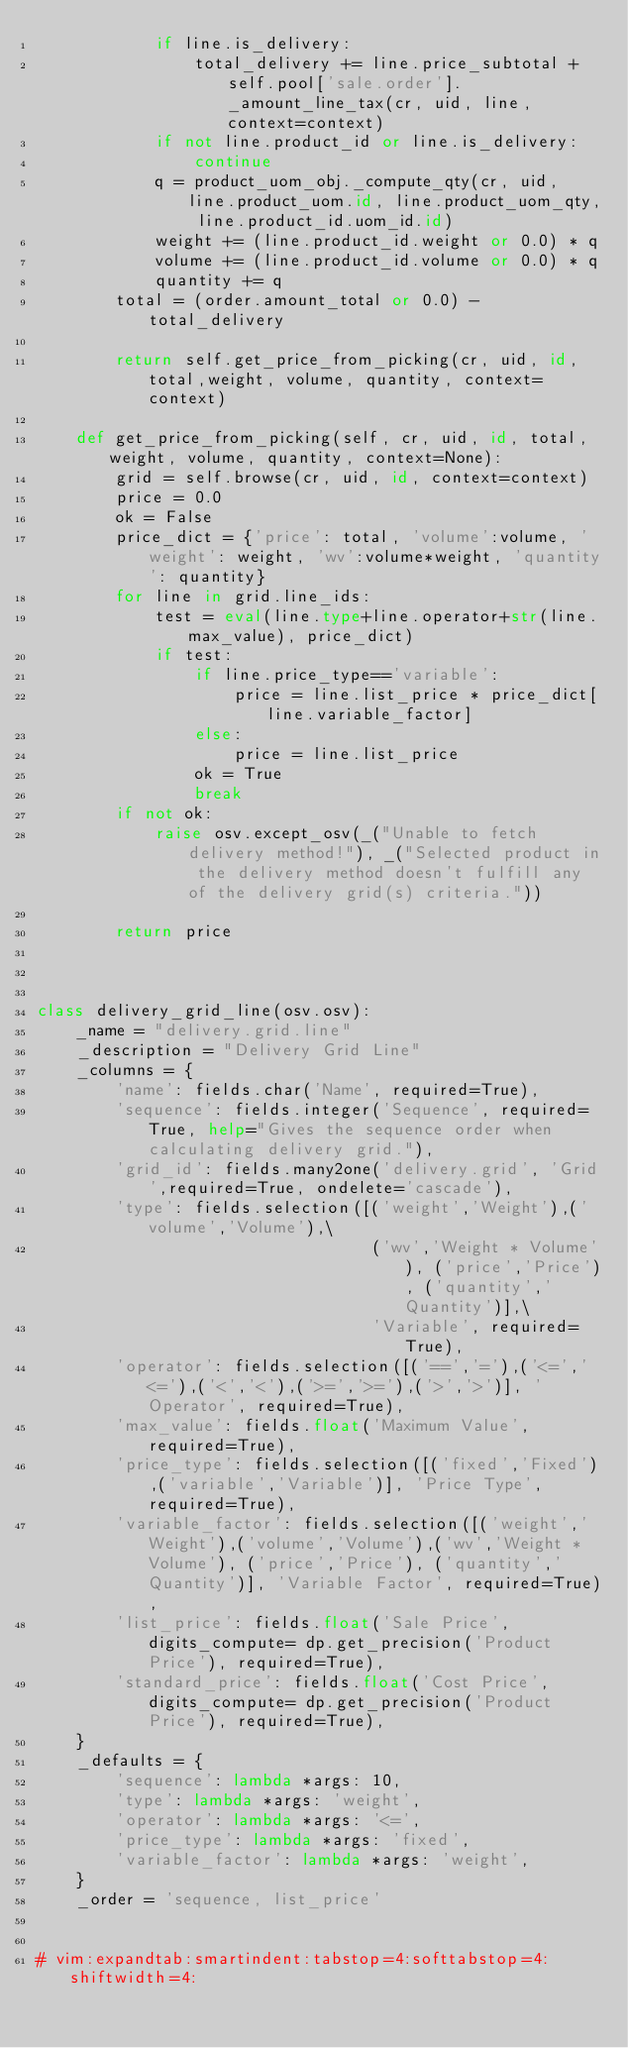<code> <loc_0><loc_0><loc_500><loc_500><_Python_>            if line.is_delivery:
                total_delivery += line.price_subtotal + self.pool['sale.order']._amount_line_tax(cr, uid, line, context=context)
            if not line.product_id or line.is_delivery:
                continue
            q = product_uom_obj._compute_qty(cr, uid, line.product_uom.id, line.product_uom_qty, line.product_id.uom_id.id)
            weight += (line.product_id.weight or 0.0) * q
            volume += (line.product_id.volume or 0.0) * q
            quantity += q
        total = (order.amount_total or 0.0) - total_delivery

        return self.get_price_from_picking(cr, uid, id, total,weight, volume, quantity, context=context)

    def get_price_from_picking(self, cr, uid, id, total, weight, volume, quantity, context=None):
        grid = self.browse(cr, uid, id, context=context)
        price = 0.0
        ok = False
        price_dict = {'price': total, 'volume':volume, 'weight': weight, 'wv':volume*weight, 'quantity': quantity}
        for line in grid.line_ids:
            test = eval(line.type+line.operator+str(line.max_value), price_dict)
            if test:
                if line.price_type=='variable':
                    price = line.list_price * price_dict[line.variable_factor]
                else:
                    price = line.list_price
                ok = True
                break
        if not ok:
            raise osv.except_osv(_("Unable to fetch delivery method!"), _("Selected product in the delivery method doesn't fulfill any of the delivery grid(s) criteria."))

        return price



class delivery_grid_line(osv.osv):
    _name = "delivery.grid.line"
    _description = "Delivery Grid Line"
    _columns = {
        'name': fields.char('Name', required=True),
        'sequence': fields.integer('Sequence', required=True, help="Gives the sequence order when calculating delivery grid."),
        'grid_id': fields.many2one('delivery.grid', 'Grid',required=True, ondelete='cascade'),
        'type': fields.selection([('weight','Weight'),('volume','Volume'),\
                                  ('wv','Weight * Volume'), ('price','Price'), ('quantity','Quantity')],\
                                  'Variable', required=True),
        'operator': fields.selection([('==','='),('<=','<='),('<','<'),('>=','>='),('>','>')], 'Operator', required=True),
        'max_value': fields.float('Maximum Value', required=True),
        'price_type': fields.selection([('fixed','Fixed'),('variable','Variable')], 'Price Type', required=True),
        'variable_factor': fields.selection([('weight','Weight'),('volume','Volume'),('wv','Weight * Volume'), ('price','Price'), ('quantity','Quantity')], 'Variable Factor', required=True),
        'list_price': fields.float('Sale Price', digits_compute= dp.get_precision('Product Price'), required=True),
        'standard_price': fields.float('Cost Price', digits_compute= dp.get_precision('Product Price'), required=True),
    }
    _defaults = {
        'sequence': lambda *args: 10,
        'type': lambda *args: 'weight',
        'operator': lambda *args: '<=',
        'price_type': lambda *args: 'fixed',
        'variable_factor': lambda *args: 'weight',
    }
    _order = 'sequence, list_price'


# vim:expandtab:smartindent:tabstop=4:softtabstop=4:shiftwidth=4:
</code> 